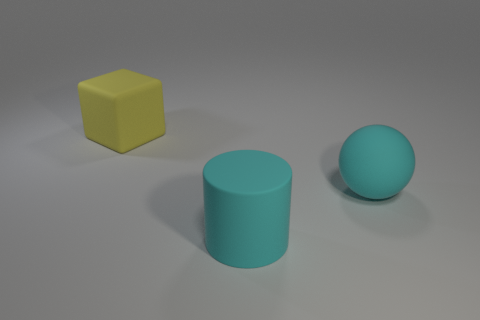Do the block and the object that is in front of the big rubber sphere have the same size?
Ensure brevity in your answer.  Yes. Is there anything else that is the same shape as the big yellow object?
Your answer should be compact. No. What number of small red metallic blocks are there?
Offer a terse response. 0. What number of yellow things are either big cylinders or big matte blocks?
Offer a terse response. 1. Is the material of the large cyan object left of the cyan matte ball the same as the yellow cube?
Provide a short and direct response. Yes. What number of other things are there of the same material as the ball
Provide a short and direct response. 2. What is the cyan cylinder made of?
Give a very brief answer. Rubber. How big is the cyan thing right of the big cyan matte cylinder?
Provide a succinct answer. Large. There is a big matte object that is on the right side of the large cyan cylinder; how many cyan balls are in front of it?
Make the answer very short. 0. There is a cyan thing to the right of the rubber cylinder; is its shape the same as the thing to the left of the big cylinder?
Provide a short and direct response. No. 